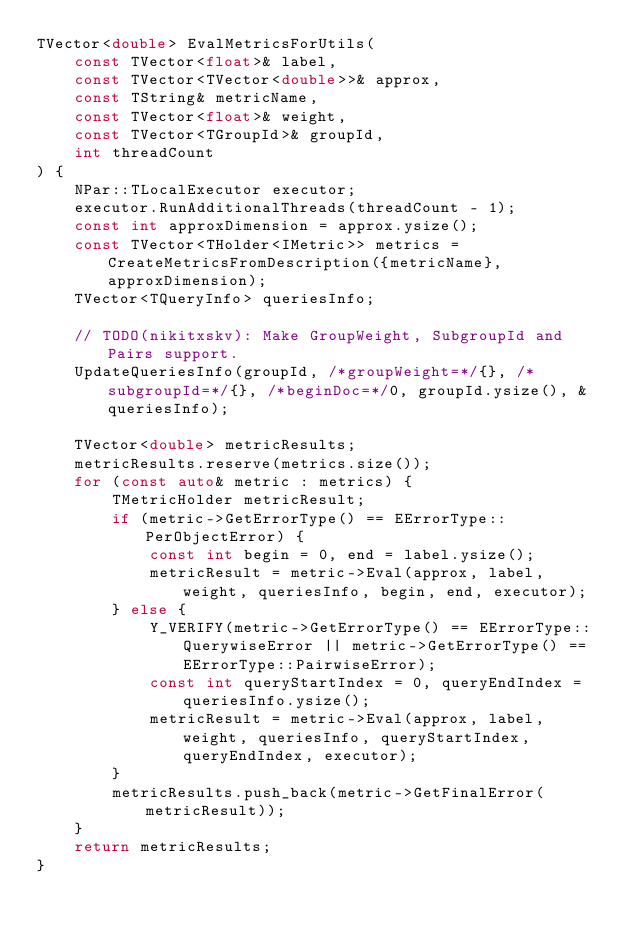<code> <loc_0><loc_0><loc_500><loc_500><_C++_>TVector<double> EvalMetricsForUtils(
    const TVector<float>& label,
    const TVector<TVector<double>>& approx,
    const TString& metricName,
    const TVector<float>& weight,
    const TVector<TGroupId>& groupId,
    int threadCount
) {
    NPar::TLocalExecutor executor;
    executor.RunAdditionalThreads(threadCount - 1);
    const int approxDimension = approx.ysize();
    const TVector<THolder<IMetric>> metrics = CreateMetricsFromDescription({metricName}, approxDimension);
    TVector<TQueryInfo> queriesInfo;

    // TODO(nikitxskv): Make GroupWeight, SubgroupId and Pairs support.
    UpdateQueriesInfo(groupId, /*groupWeight=*/{}, /*subgroupId=*/{}, /*beginDoc=*/0, groupId.ysize(), &queriesInfo);

    TVector<double> metricResults;
    metricResults.reserve(metrics.size());
    for (const auto& metric : metrics) {
        TMetricHolder metricResult;
        if (metric->GetErrorType() == EErrorType::PerObjectError) {
            const int begin = 0, end = label.ysize();
            metricResult = metric->Eval(approx, label, weight, queriesInfo, begin, end, executor);
        } else {
            Y_VERIFY(metric->GetErrorType() == EErrorType::QuerywiseError || metric->GetErrorType() == EErrorType::PairwiseError);
            const int queryStartIndex = 0, queryEndIndex = queriesInfo.ysize();
            metricResult = metric->Eval(approx, label, weight, queriesInfo, queryStartIndex, queryEndIndex, executor);
        }
        metricResults.push_back(metric->GetFinalError(metricResult));
    }
    return metricResults;
}
</code> 